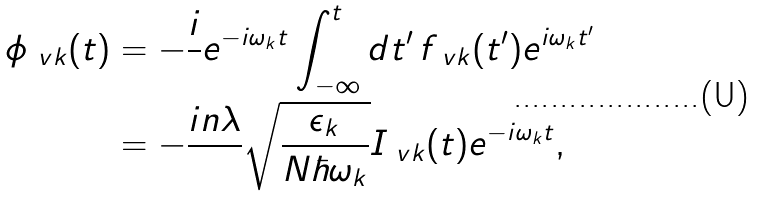<formula> <loc_0><loc_0><loc_500><loc_500>\phi _ { \ v k } ( t ) & = - \frac { i } { } e ^ { - i \omega _ { k } t } \int ^ { t } _ { - \infty } d t ^ { \prime } \, f _ { \ v k } ( t ^ { \prime } ) e ^ { i \omega _ { k } t ^ { \prime } } \\ & = - \frac { i n \lambda } { } \sqrt { \frac { \epsilon _ { k } } { N \hbar { \omega } _ { k } } } I _ { \ v k } ( t ) e ^ { - i \omega _ { k } t } ,</formula> 